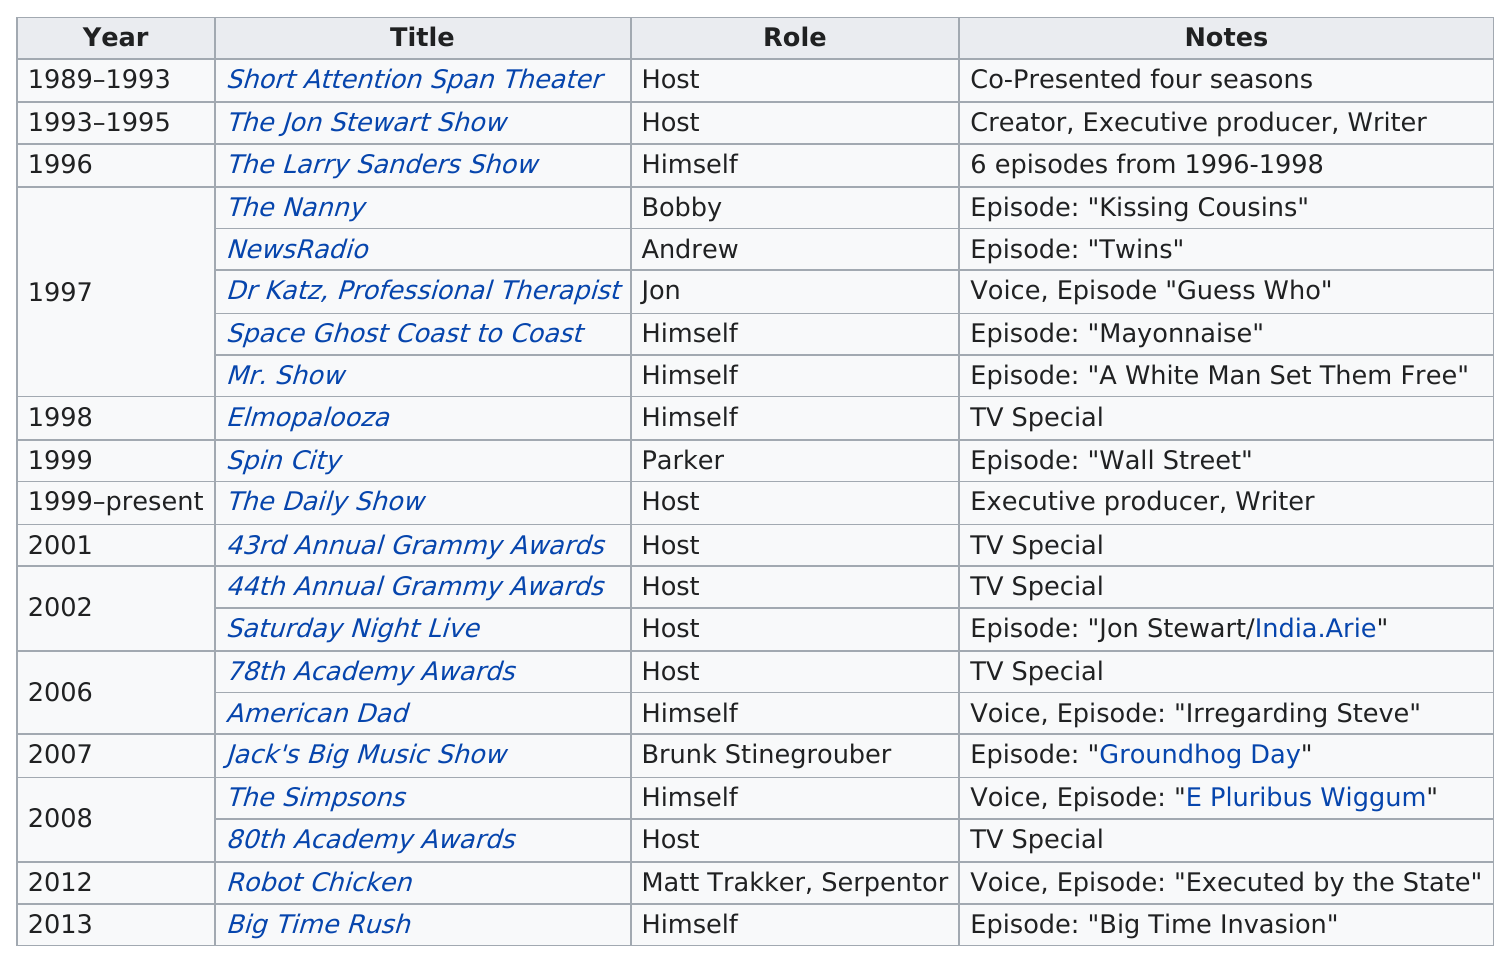Identify some key points in this picture. Stewart has received writing credit on two shows. John Stewart has held The Daily Show for the longest period of time among all the shows he has hosted. Jon Stewart performs 8 roles in the role of host. After hosting the 44th Annual Grammy Awards, Stewart hosted the 78th Academy Awards. Jon Stewart had four more roles in 1997 compared to 2007. 